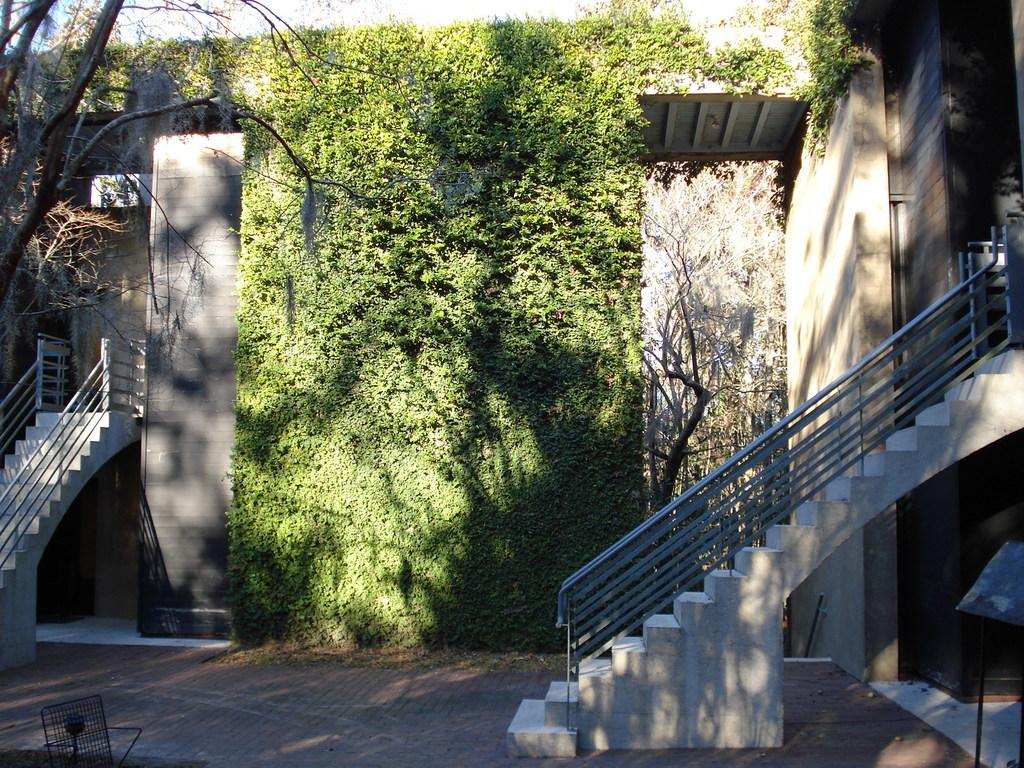What type of structures can be seen in the image? There are buildings in the image. What architectural feature is present in the image? There are stairs and a railing in the image. What type of vegetation is present in the image? Dry trees and plants are visible in the image. What part of the buildings can be seen in the image? There is a roof in the image. What is visible at the bottom of the image? The floor is visible at the bottom of the image. What is visible at the top of the image? The sky is visible at the top of the image. What color is the silver hope depicted in the image? There is no silver hope present in the image. Can you tell me how many times the person swims in the image? There is no person swimming in the image. 